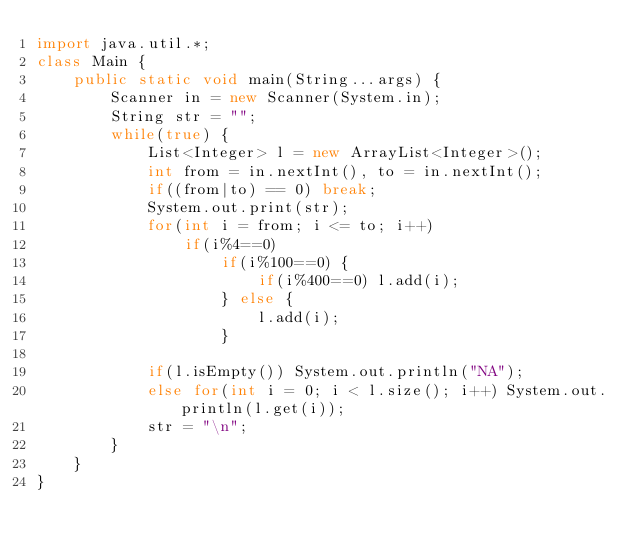Convert code to text. <code><loc_0><loc_0><loc_500><loc_500><_Java_>import java.util.*;
class Main {
	public static void main(String...args) {
		Scanner in = new Scanner(System.in);
		String str = "";
		while(true) {
			List<Integer> l = new ArrayList<Integer>();
			int from = in.nextInt(), to = in.nextInt();
			if((from|to) == 0) break;
			System.out.print(str);
			for(int i = from; i <= to; i++)
				if(i%4==0)
					if(i%100==0) {
						if(i%400==0) l.add(i);
					} else {
						l.add(i);
					}

			if(l.isEmpty()) System.out.println("NA");
			else for(int i = 0; i < l.size(); i++) System.out.println(l.get(i));
			str = "\n";
		}
	}
}</code> 